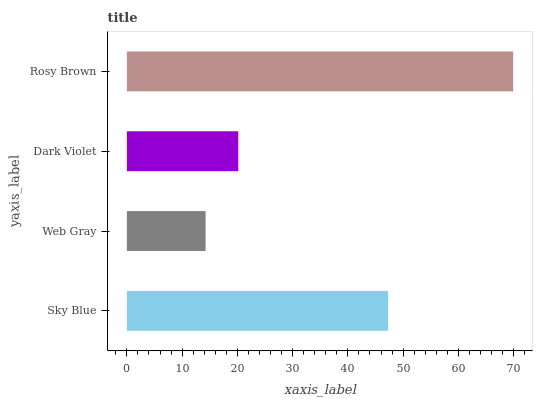Is Web Gray the minimum?
Answer yes or no. Yes. Is Rosy Brown the maximum?
Answer yes or no. Yes. Is Dark Violet the minimum?
Answer yes or no. No. Is Dark Violet the maximum?
Answer yes or no. No. Is Dark Violet greater than Web Gray?
Answer yes or no. Yes. Is Web Gray less than Dark Violet?
Answer yes or no. Yes. Is Web Gray greater than Dark Violet?
Answer yes or no. No. Is Dark Violet less than Web Gray?
Answer yes or no. No. Is Sky Blue the high median?
Answer yes or no. Yes. Is Dark Violet the low median?
Answer yes or no. Yes. Is Dark Violet the high median?
Answer yes or no. No. Is Rosy Brown the low median?
Answer yes or no. No. 